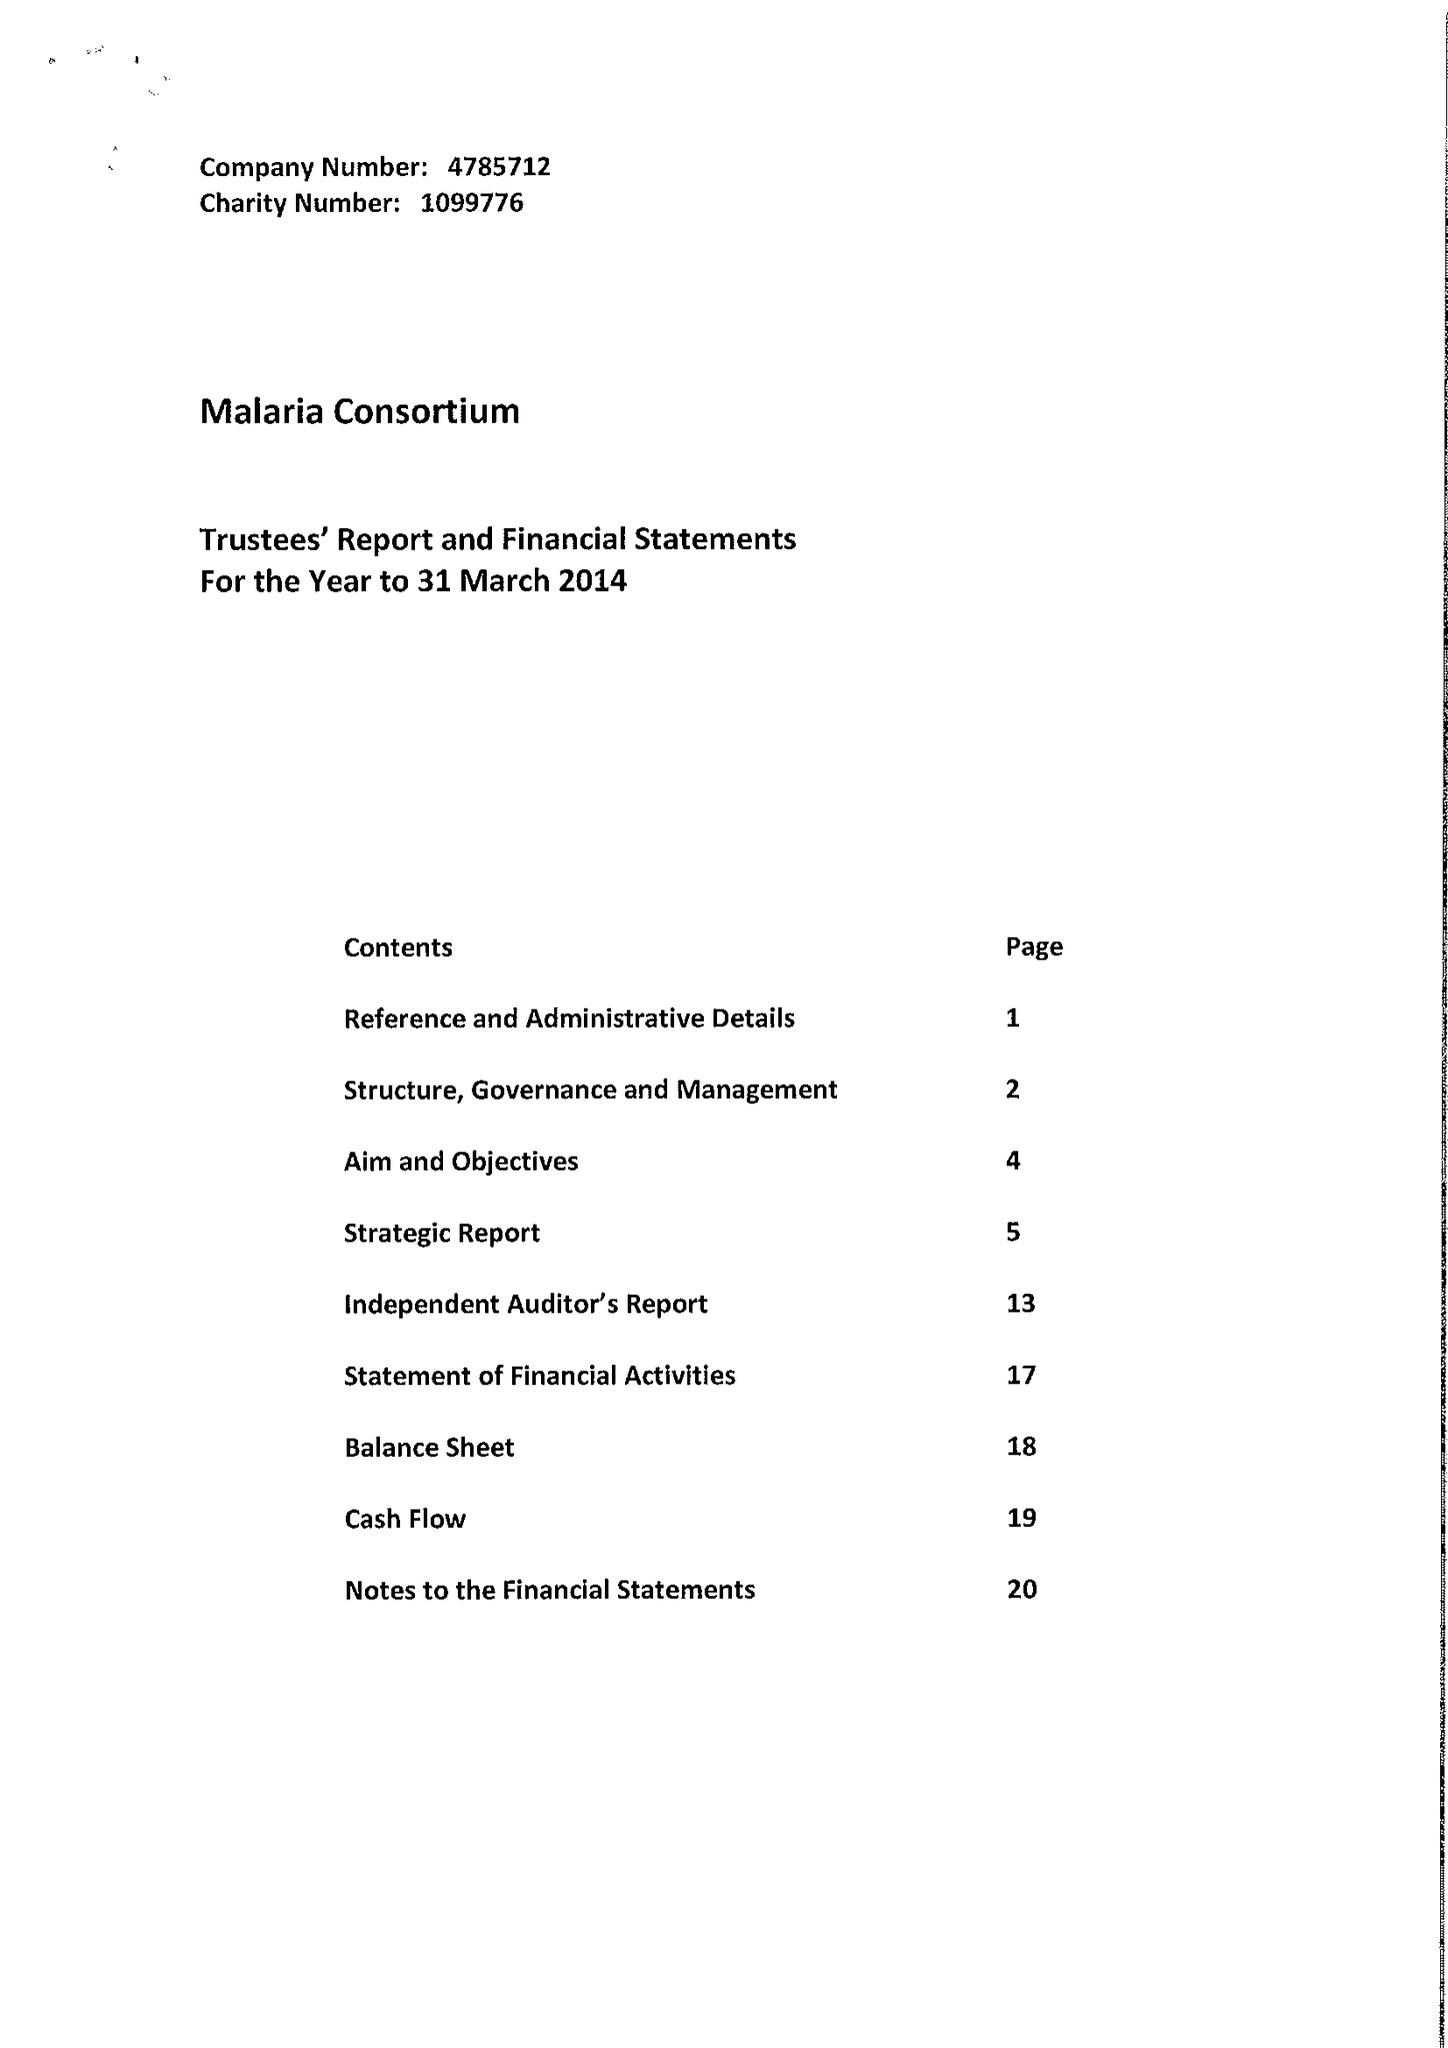What is the value for the spending_annually_in_british_pounds?
Answer the question using a single word or phrase. 55102824.00 